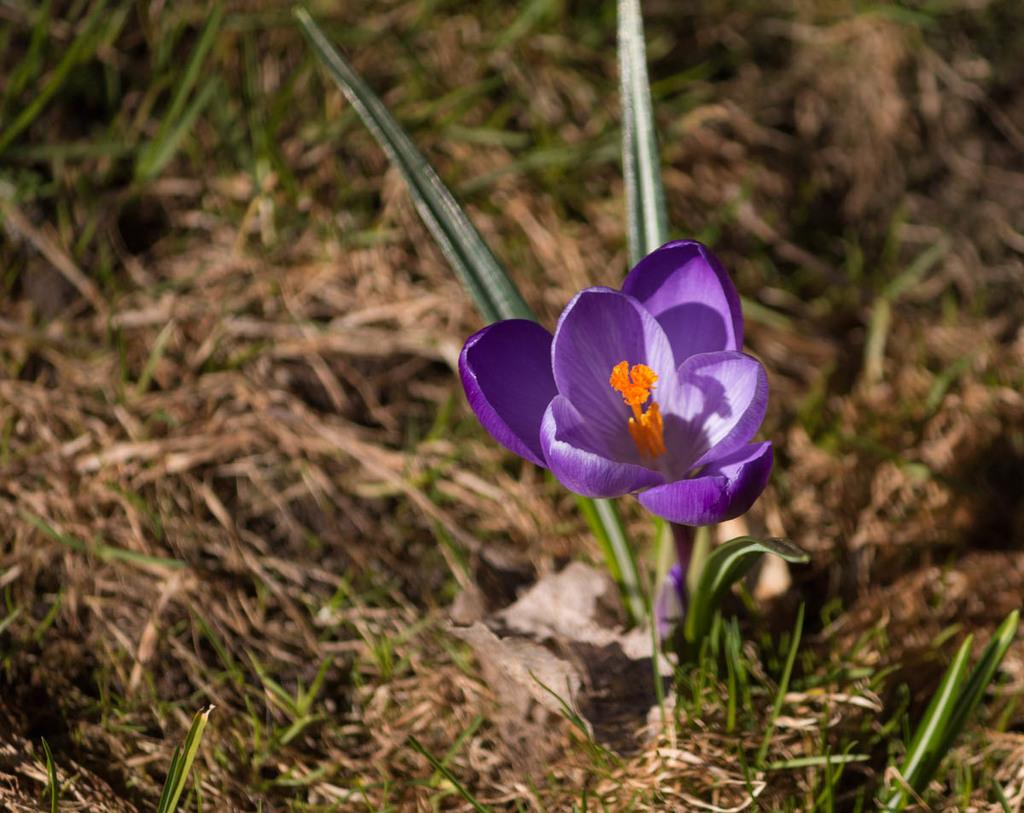What is the main subject of the image? There is a flower in the image. Can you describe the colors of the flower? The flower has violet and orange colors. Where is the flower located in the image? The flower is on the ground. What type of vegetation is visible in the image? There is grass and other plants visible in the image. How much debt does the flower have in the image? There is no indication of debt in the image, as it features a flower with violet and orange colors on the ground. Can you tell me which toe is closest to the flower in the image? There are no toes or people present in the image, so it is not possible to determine which toe might be closest to the flower. 